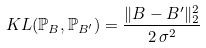Convert formula to latex. <formula><loc_0><loc_0><loc_500><loc_500>K L ( \mathbb { P } _ { B } , \mathbb { P } _ { B ^ { \prime } } ) = \frac { \| B - B ^ { \prime } \| ^ { 2 } _ { 2 } } { 2 \, \sigma ^ { 2 } }</formula> 